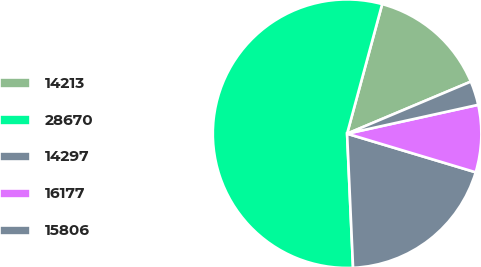Convert chart to OTSL. <chart><loc_0><loc_0><loc_500><loc_500><pie_chart><fcel>14213<fcel>28670<fcel>14297<fcel>16177<fcel>15806<nl><fcel>14.45%<fcel>54.91%<fcel>19.65%<fcel>8.09%<fcel>2.89%<nl></chart> 